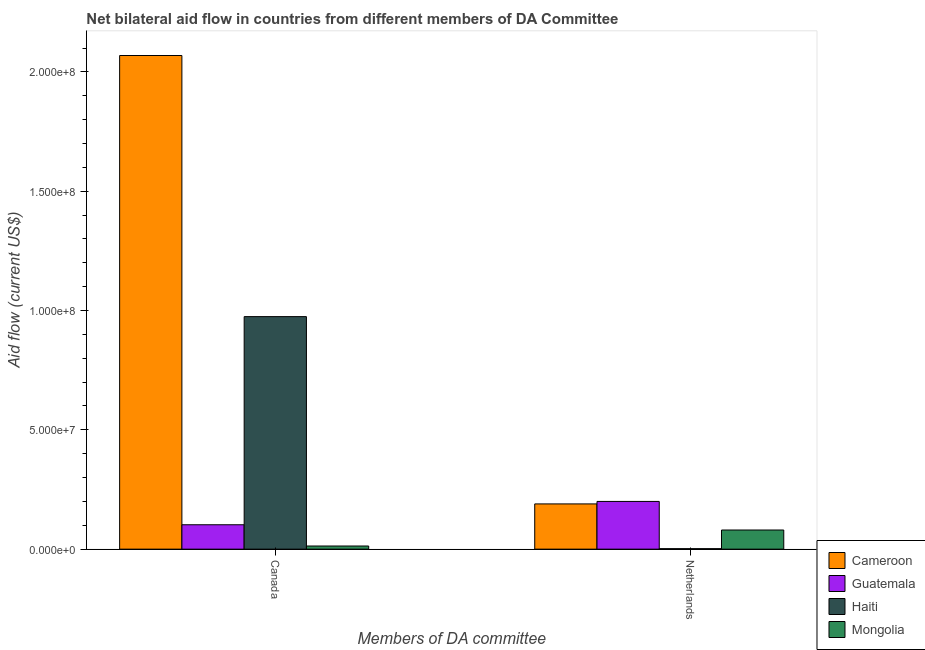How many different coloured bars are there?
Your response must be concise. 4. How many groups of bars are there?
Ensure brevity in your answer.  2. Are the number of bars per tick equal to the number of legend labels?
Make the answer very short. Yes. How many bars are there on the 2nd tick from the left?
Provide a short and direct response. 4. How many bars are there on the 2nd tick from the right?
Offer a terse response. 4. What is the label of the 2nd group of bars from the left?
Ensure brevity in your answer.  Netherlands. What is the amount of aid given by netherlands in Guatemala?
Give a very brief answer. 2.00e+07. Across all countries, what is the maximum amount of aid given by netherlands?
Make the answer very short. 2.00e+07. Across all countries, what is the minimum amount of aid given by canada?
Provide a short and direct response. 1.32e+06. In which country was the amount of aid given by netherlands maximum?
Keep it short and to the point. Guatemala. In which country was the amount of aid given by canada minimum?
Give a very brief answer. Mongolia. What is the total amount of aid given by netherlands in the graph?
Make the answer very short. 4.72e+07. What is the difference between the amount of aid given by canada in Cameroon and that in Haiti?
Provide a short and direct response. 1.09e+08. What is the difference between the amount of aid given by netherlands in Cameroon and the amount of aid given by canada in Guatemala?
Ensure brevity in your answer.  8.74e+06. What is the average amount of aid given by canada per country?
Offer a very short reply. 7.90e+07. What is the difference between the amount of aid given by netherlands and amount of aid given by canada in Haiti?
Offer a terse response. -9.72e+07. In how many countries, is the amount of aid given by netherlands greater than 10000000 US$?
Offer a terse response. 2. What is the ratio of the amount of aid given by netherlands in Haiti to that in Cameroon?
Give a very brief answer. 0.01. In how many countries, is the amount of aid given by netherlands greater than the average amount of aid given by netherlands taken over all countries?
Your response must be concise. 2. What does the 1st bar from the left in Netherlands represents?
Make the answer very short. Cameroon. What does the 4th bar from the right in Canada represents?
Provide a succinct answer. Cameroon. Are all the bars in the graph horizontal?
Provide a succinct answer. No. What is the difference between two consecutive major ticks on the Y-axis?
Provide a short and direct response. 5.00e+07. Are the values on the major ticks of Y-axis written in scientific E-notation?
Provide a short and direct response. Yes. Does the graph contain grids?
Offer a very short reply. No. How many legend labels are there?
Your answer should be compact. 4. What is the title of the graph?
Offer a terse response. Net bilateral aid flow in countries from different members of DA Committee. Does "Puerto Rico" appear as one of the legend labels in the graph?
Ensure brevity in your answer.  No. What is the label or title of the X-axis?
Offer a very short reply. Members of DA committee. What is the label or title of the Y-axis?
Make the answer very short. Aid flow (current US$). What is the Aid flow (current US$) of Cameroon in Canada?
Ensure brevity in your answer.  2.07e+08. What is the Aid flow (current US$) of Guatemala in Canada?
Keep it short and to the point. 1.02e+07. What is the Aid flow (current US$) of Haiti in Canada?
Offer a terse response. 9.74e+07. What is the Aid flow (current US$) of Mongolia in Canada?
Make the answer very short. 1.32e+06. What is the Aid flow (current US$) of Cameroon in Netherlands?
Ensure brevity in your answer.  1.90e+07. What is the Aid flow (current US$) of Mongolia in Netherlands?
Offer a very short reply. 8.02e+06. Across all Members of DA committee, what is the maximum Aid flow (current US$) of Cameroon?
Your response must be concise. 2.07e+08. Across all Members of DA committee, what is the maximum Aid flow (current US$) in Haiti?
Your response must be concise. 9.74e+07. Across all Members of DA committee, what is the maximum Aid flow (current US$) of Mongolia?
Offer a terse response. 8.02e+06. Across all Members of DA committee, what is the minimum Aid flow (current US$) of Cameroon?
Provide a succinct answer. 1.90e+07. Across all Members of DA committee, what is the minimum Aid flow (current US$) of Guatemala?
Your answer should be compact. 1.02e+07. Across all Members of DA committee, what is the minimum Aid flow (current US$) in Mongolia?
Make the answer very short. 1.32e+06. What is the total Aid flow (current US$) in Cameroon in the graph?
Provide a succinct answer. 2.26e+08. What is the total Aid flow (current US$) in Guatemala in the graph?
Give a very brief answer. 3.02e+07. What is the total Aid flow (current US$) of Haiti in the graph?
Offer a very short reply. 9.76e+07. What is the total Aid flow (current US$) in Mongolia in the graph?
Ensure brevity in your answer.  9.34e+06. What is the difference between the Aid flow (current US$) in Cameroon in Canada and that in Netherlands?
Offer a terse response. 1.88e+08. What is the difference between the Aid flow (current US$) of Guatemala in Canada and that in Netherlands?
Your answer should be very brief. -9.78e+06. What is the difference between the Aid flow (current US$) of Haiti in Canada and that in Netherlands?
Your response must be concise. 9.72e+07. What is the difference between the Aid flow (current US$) of Mongolia in Canada and that in Netherlands?
Your answer should be very brief. -6.70e+06. What is the difference between the Aid flow (current US$) in Cameroon in Canada and the Aid flow (current US$) in Guatemala in Netherlands?
Your answer should be compact. 1.87e+08. What is the difference between the Aid flow (current US$) of Cameroon in Canada and the Aid flow (current US$) of Haiti in Netherlands?
Your answer should be very brief. 2.07e+08. What is the difference between the Aid flow (current US$) of Cameroon in Canada and the Aid flow (current US$) of Mongolia in Netherlands?
Your response must be concise. 1.99e+08. What is the difference between the Aid flow (current US$) of Guatemala in Canada and the Aid flow (current US$) of Haiti in Netherlands?
Ensure brevity in your answer.  1.00e+07. What is the difference between the Aid flow (current US$) of Guatemala in Canada and the Aid flow (current US$) of Mongolia in Netherlands?
Offer a very short reply. 2.20e+06. What is the difference between the Aid flow (current US$) in Haiti in Canada and the Aid flow (current US$) in Mongolia in Netherlands?
Offer a terse response. 8.94e+07. What is the average Aid flow (current US$) of Cameroon per Members of DA committee?
Your response must be concise. 1.13e+08. What is the average Aid flow (current US$) in Guatemala per Members of DA committee?
Provide a short and direct response. 1.51e+07. What is the average Aid flow (current US$) in Haiti per Members of DA committee?
Your answer should be very brief. 4.88e+07. What is the average Aid flow (current US$) in Mongolia per Members of DA committee?
Your response must be concise. 4.67e+06. What is the difference between the Aid flow (current US$) in Cameroon and Aid flow (current US$) in Guatemala in Canada?
Offer a terse response. 1.97e+08. What is the difference between the Aid flow (current US$) in Cameroon and Aid flow (current US$) in Haiti in Canada?
Provide a succinct answer. 1.09e+08. What is the difference between the Aid flow (current US$) of Cameroon and Aid flow (current US$) of Mongolia in Canada?
Your answer should be very brief. 2.06e+08. What is the difference between the Aid flow (current US$) in Guatemala and Aid flow (current US$) in Haiti in Canada?
Your answer should be very brief. -8.72e+07. What is the difference between the Aid flow (current US$) in Guatemala and Aid flow (current US$) in Mongolia in Canada?
Ensure brevity in your answer.  8.90e+06. What is the difference between the Aid flow (current US$) in Haiti and Aid flow (current US$) in Mongolia in Canada?
Make the answer very short. 9.61e+07. What is the difference between the Aid flow (current US$) in Cameroon and Aid flow (current US$) in Guatemala in Netherlands?
Your response must be concise. -1.04e+06. What is the difference between the Aid flow (current US$) of Cameroon and Aid flow (current US$) of Haiti in Netherlands?
Provide a short and direct response. 1.88e+07. What is the difference between the Aid flow (current US$) in Cameroon and Aid flow (current US$) in Mongolia in Netherlands?
Your answer should be very brief. 1.09e+07. What is the difference between the Aid flow (current US$) in Guatemala and Aid flow (current US$) in Haiti in Netherlands?
Offer a very short reply. 1.98e+07. What is the difference between the Aid flow (current US$) in Guatemala and Aid flow (current US$) in Mongolia in Netherlands?
Offer a terse response. 1.20e+07. What is the difference between the Aid flow (current US$) in Haiti and Aid flow (current US$) in Mongolia in Netherlands?
Your answer should be very brief. -7.82e+06. What is the ratio of the Aid flow (current US$) of Cameroon in Canada to that in Netherlands?
Keep it short and to the point. 10.91. What is the ratio of the Aid flow (current US$) of Guatemala in Canada to that in Netherlands?
Make the answer very short. 0.51. What is the ratio of the Aid flow (current US$) in Haiti in Canada to that in Netherlands?
Your answer should be compact. 487.25. What is the ratio of the Aid flow (current US$) in Mongolia in Canada to that in Netherlands?
Your answer should be compact. 0.16. What is the difference between the highest and the second highest Aid flow (current US$) in Cameroon?
Your answer should be very brief. 1.88e+08. What is the difference between the highest and the second highest Aid flow (current US$) in Guatemala?
Your answer should be very brief. 9.78e+06. What is the difference between the highest and the second highest Aid flow (current US$) of Haiti?
Ensure brevity in your answer.  9.72e+07. What is the difference between the highest and the second highest Aid flow (current US$) in Mongolia?
Ensure brevity in your answer.  6.70e+06. What is the difference between the highest and the lowest Aid flow (current US$) in Cameroon?
Your answer should be very brief. 1.88e+08. What is the difference between the highest and the lowest Aid flow (current US$) in Guatemala?
Ensure brevity in your answer.  9.78e+06. What is the difference between the highest and the lowest Aid flow (current US$) in Haiti?
Make the answer very short. 9.72e+07. What is the difference between the highest and the lowest Aid flow (current US$) of Mongolia?
Your answer should be very brief. 6.70e+06. 